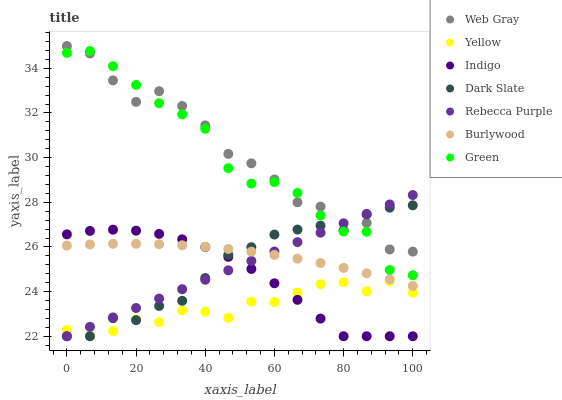Does Yellow have the minimum area under the curve?
Answer yes or no. Yes. Does Web Gray have the maximum area under the curve?
Answer yes or no. Yes. Does Indigo have the minimum area under the curve?
Answer yes or no. No. Does Indigo have the maximum area under the curve?
Answer yes or no. No. Is Rebecca Purple the smoothest?
Answer yes or no. Yes. Is Web Gray the roughest?
Answer yes or no. Yes. Is Indigo the smoothest?
Answer yes or no. No. Is Indigo the roughest?
Answer yes or no. No. Does Indigo have the lowest value?
Answer yes or no. Yes. Does Burlywood have the lowest value?
Answer yes or no. No. Does Web Gray have the highest value?
Answer yes or no. Yes. Does Indigo have the highest value?
Answer yes or no. No. Is Yellow less than Web Gray?
Answer yes or no. Yes. Is Green greater than Burlywood?
Answer yes or no. Yes. Does Web Gray intersect Green?
Answer yes or no. Yes. Is Web Gray less than Green?
Answer yes or no. No. Is Web Gray greater than Green?
Answer yes or no. No. Does Yellow intersect Web Gray?
Answer yes or no. No. 